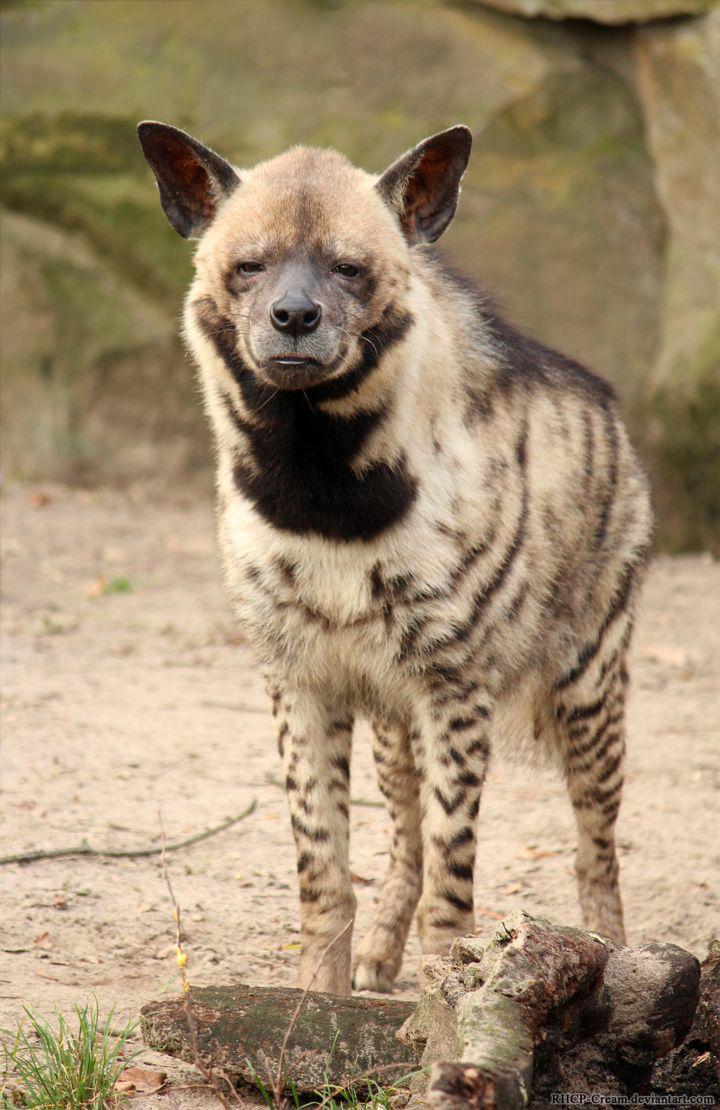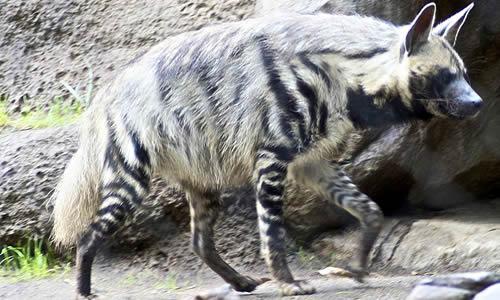The first image is the image on the left, the second image is the image on the right. Given the left and right images, does the statement "A hyena has its body and face turned toward the camera." hold true? Answer yes or no. Yes. The first image is the image on the left, the second image is the image on the right. Analyze the images presented: Is the assertion "there is exactly one animal lying down in one of the images" valid? Answer yes or no. No. 